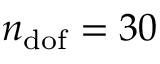<formula> <loc_0><loc_0><loc_500><loc_500>n _ { d o f } = 3 0</formula> 